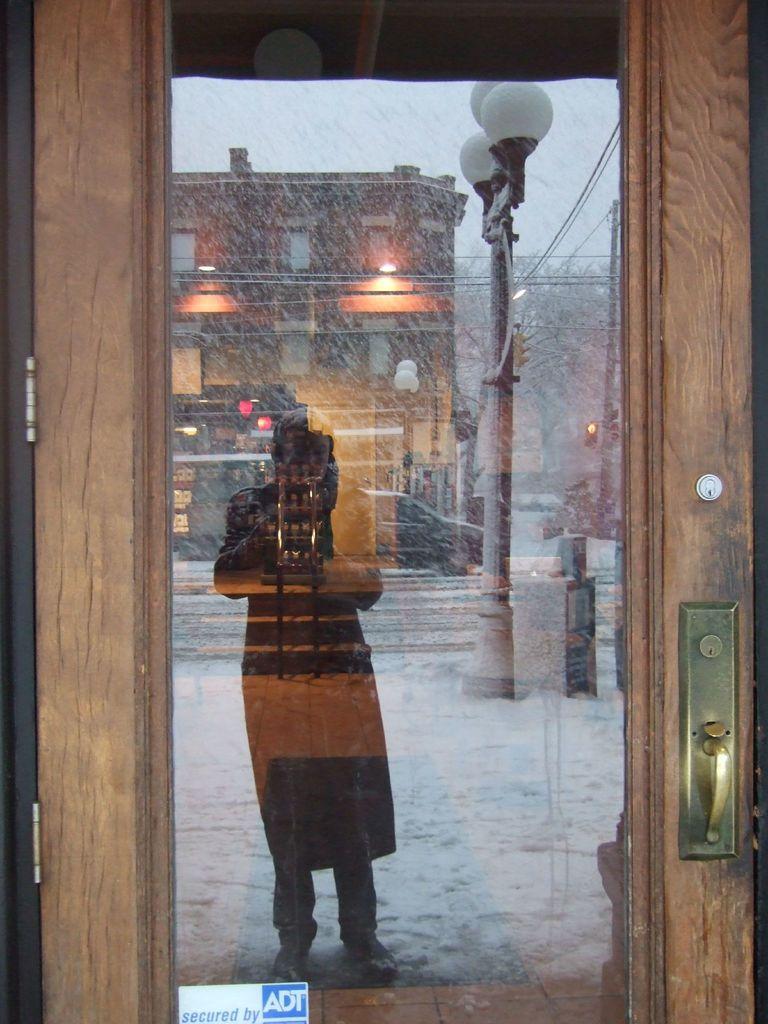Can you describe this image briefly? In this picture we can see a glass door in the front, we can see reflection of a person, a car, a pole, lights, a building, a tree and the sky on the glass. 